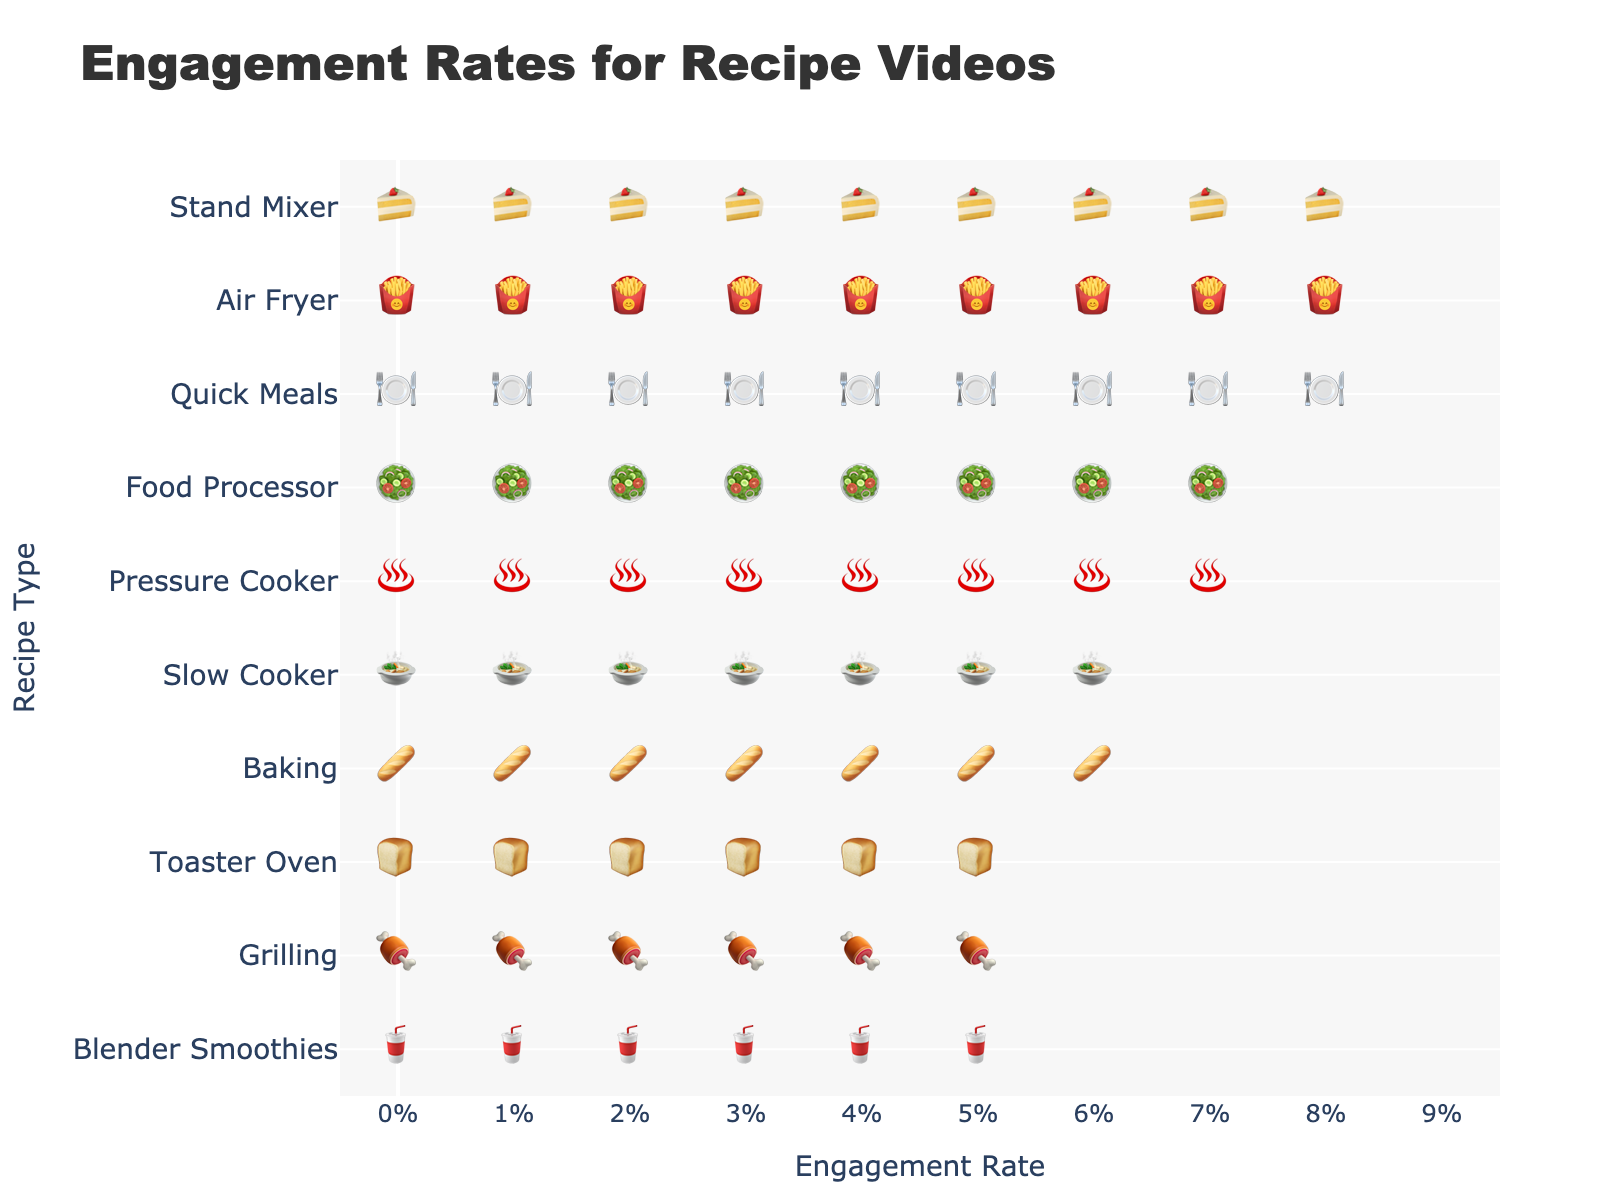What is the title of the plot? The title of the plot is clearly written at the top in larger and bold text. The title is "Engagement Rates for Recipe Videos".
Answer: Engagement Rates for Recipe Videos Which recipe type has the highest engagement rate? By looking at the icons representing engagement rates and finding the one with the highest count, the "Air Fryer" recipe type has the most icons (9 icons), representing the highest engagement rate.
Answer: Air Fryer How many recipe types have an engagement rate of 8% or above? Counting the number of recipe types with 8 or more icons, "Quick Meals", "Air Fryer", "Pressure Cooker", "Stand Mixer", and "Food Processor" have 8 or more icons. These represent 8.5%, 9.3%, 8.1%, 8.9%, and 7.7% engagement rates respectively.
Answer: 5 What is the difference in engagement rates between "Air Fryer" and "Blender Smoothies"? The engagement rate for "Air Fryer" is 9.3% and for "Blender Smoothies" is 5.6%. Subtracting the two: 9.3% - 5.6% = 3.7%.
Answer: 3.7% Which recipe type has the lowest engagement rate? By comparing the number of icons, "Blender Smoothies" and "Toaster Oven" both have the fewest icons (6 icons), but "Blender Smoothies" has a rate of 5.6% versus "Toaster Oven"'s 5.9%. The lowest is thus "Blender Smoothies".
Answer: Blender Smoothies What is the median engagement rate of all the recipe types? Listing all the engagement rates in ascending order: 5.6%, 5.9%, 6.4%, 6.8%, 7.2%, 7.7%, 8.1%, 8.5%, 8.9%, 9.3% and finding the middle value, as there are ten values, we take the average of the 5th and 6th values: (7.2% + 7.7%) / 2 = 7.45%.
Answer: 7.45% Which two recipe types have exactly 8% engagement rate? There are no exact 8% engagement rates visible in the plot. The closest values are above or below 8%.
Answer: None 